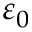<formula> <loc_0><loc_0><loc_500><loc_500>\varepsilon _ { 0 }</formula> 